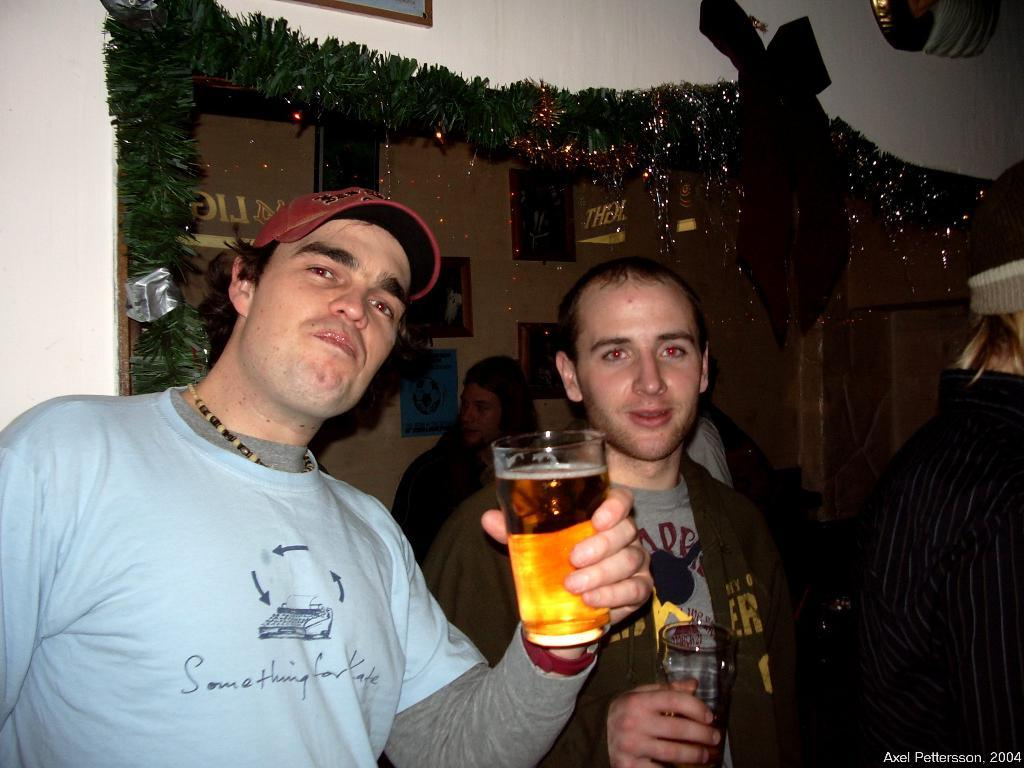Who or what can be seen in the image? There are people in the image. What object is visible in the image that might be used for drinking? There is a glass in the image. What accessory is present in the image? There is a cap in the image. What type of jewelry can be seen in the image? There is a neck-chain in the image. What is hanging on the wall in the image? There is a photo frame on the wall in the image. What is the watermark in the image? There is a watermark in the image. How does the boat move in the image? There is no boat present in the image. 